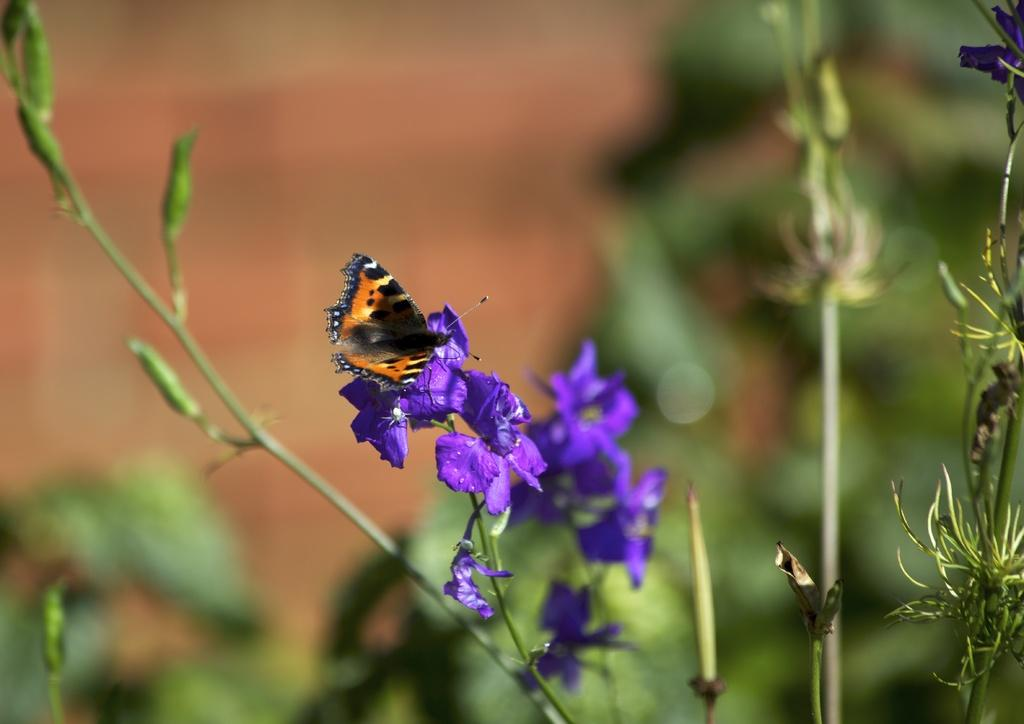What is the main subject of the image? There is a butterfly in the image. What is the butterfly resting on? The butterfly is on purple flowers. What can be seen in the background of the image? There are trees in the background of the image. How would you describe the background of the image? The background is blurry. What type of selection process is being used to choose the best angle for the harbor in the image? There is no harbor present in the image, so there is no selection process or angle to discuss. 